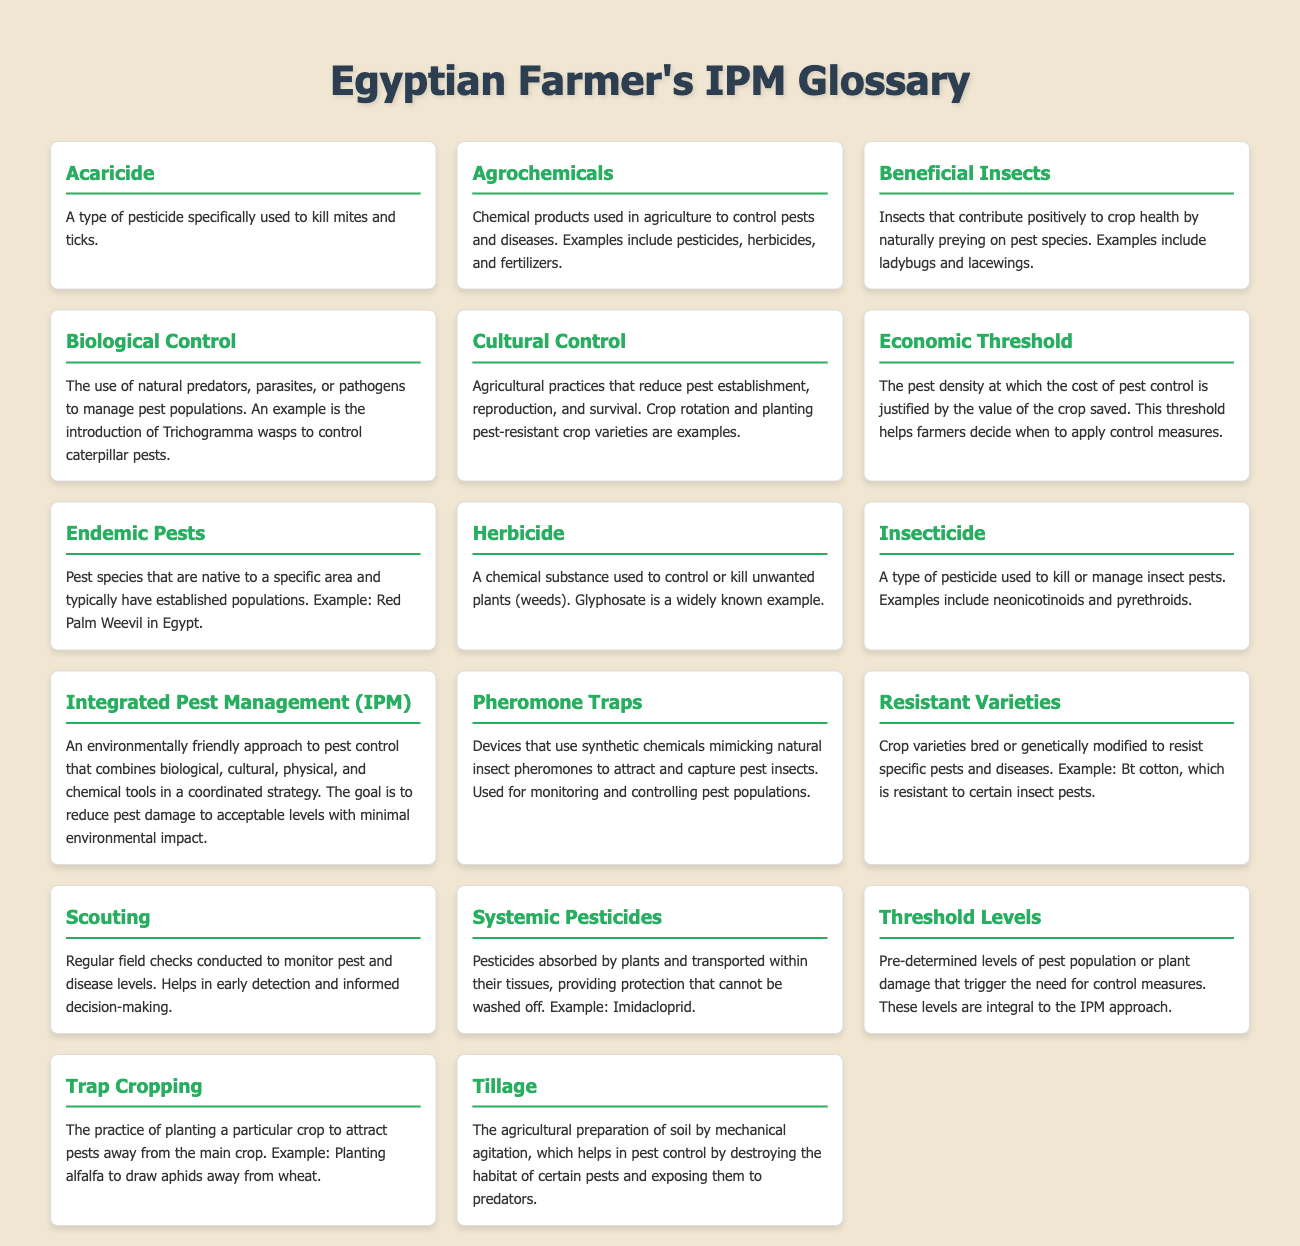What is an Acaricide? An Acaricide is a type of pesticide specifically used to kill mites and ticks.
Answer: A pesticide for mites and ticks What is the definition of Biological Control? Biological Control is the use of natural predators, parasites, or pathogens to manage pest populations.
Answer: Use of natural predators to manage pests What does IPM stand for? IPM stands for Integrated Pest Management.
Answer: Integrated Pest Management What are Beneficial Insects? Beneficial Insects are insects that contribute positively to crop health by naturally preying on pest species.
Answer: Insects that prey on pests What is the purpose of Pheromone Traps? Pheromone Traps are devices that use synthetic chemicals mimicking natural insect pheromones to attract and capture pest insects.
Answer: To attract and capture pest insects What is an example of a Resistant Variety? An example of a Resistant Variety is Bt cotton, which is resistant to certain insect pests.
Answer: Bt cotton What are Economic Thresholds used for in pest management? Economic Thresholds help farmers decide when to apply control measures based on pest density and crop value.
Answer: To decide when to apply control measures What agricultural practice is referred to as Cultural Control? Cultural Control includes agricultural practices such as crop rotation and planting pest-resistant crop varieties to reduce pests.
Answer: Crop rotation and planting resistant varieties What do Threshold Levels indicate? Threshold Levels are pre-determined levels of pest population or plant damage that trigger the need for control measures.
Answer: Trigger levels for control measures 